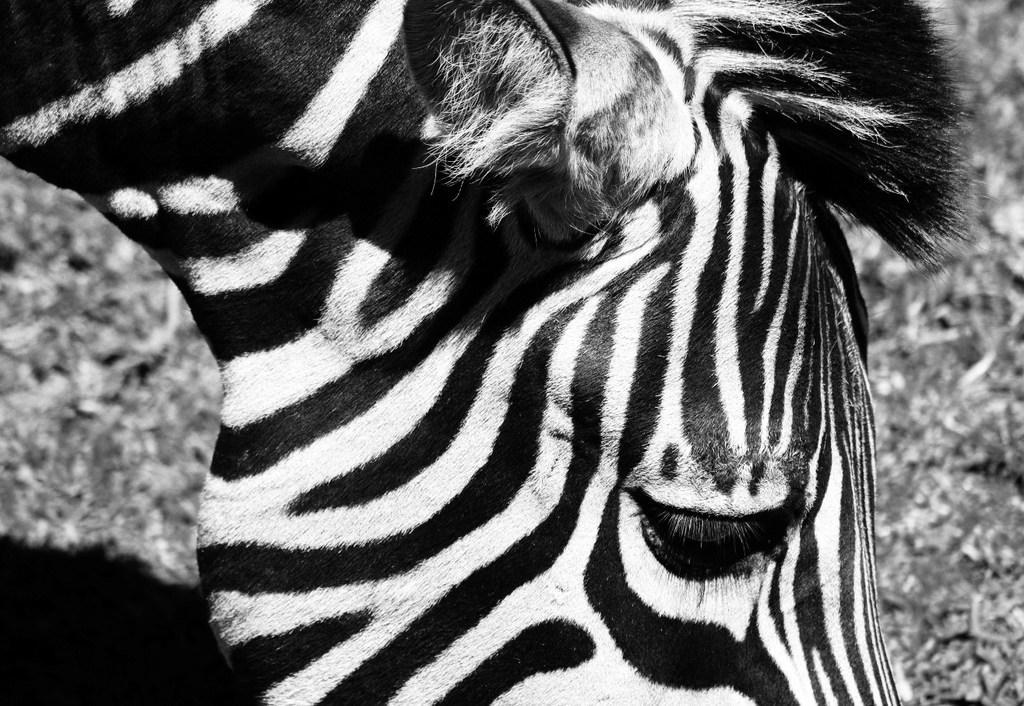Please provide a concise description of this image. This image consists of a zebra. The image looks like black and white. At the bottom, there is ground. 